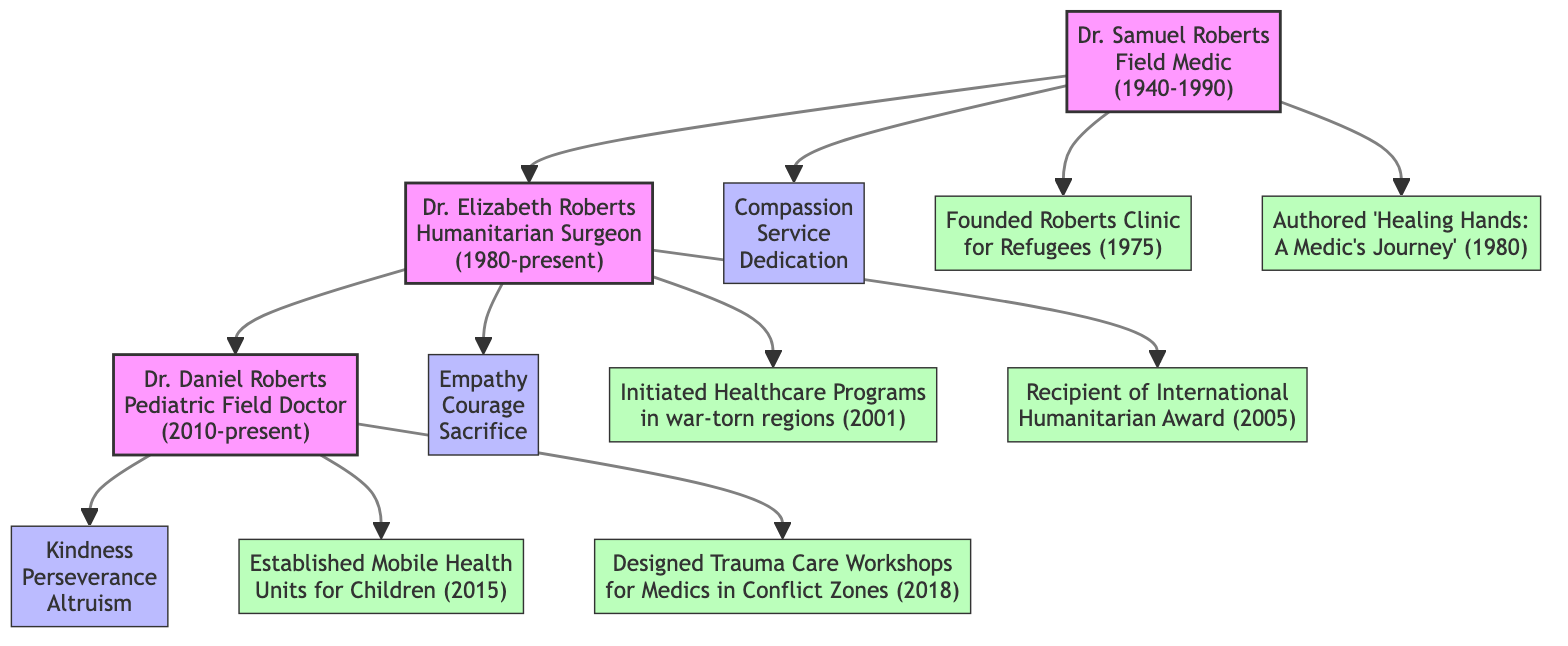What values did Dr. Samuel Roberts emphasize? The diagram indicates that Dr. Samuel Roberts emphasized three values: Compassion, Service, and Dedication. These values are displayed as nodes directly connected to his name.
Answer: Compassion, Service, Dedication Who initiated healthcare programs in war-torn regions? According to the diagram, Dr. Elizabeth Roberts is responsible for initiating healthcare programs in war-torn regions, as shown by the associated achievement node linked to her.
Answer: Dr. Elizabeth Roberts How many notable achievements does Dr. Daniel Roberts have listed? The diagram shows two notable achievements directly connected to Dr. Daniel Roberts. By counting the edges leading to his achievement nodes, we confirm the total.
Answer: 2 What is Dr. Elizabeth Roberts' notable award? The diagram states that Dr. Elizabeth Roberts received the International Humanitarian Award, which is listed as one of her notable achievements.
Answer: International Humanitarian Award Which family member worked as a Pediatric Field Doctor? The diagram clearly indicates that Dr. Daniel Roberts holds the title of Pediatric Field Doctor, linking it directly to his name.
Answer: Dr. Daniel Roberts What year was the Roberts Clinic for Refugees founded? The diagram specifies that the Roberts Clinic for Refugees was founded in 1975, which is indicated beside the achievement node for Dr. Samuel Roberts.
Answer: 1975 What values are associated with Dr. Daniel Roberts? Dr. Daniel Roberts is associated with three values: Kindness, Perseverance, and Altruism, which are linked to him in the diagram.
Answer: Kindness, Perseverance, Altruism Who is connected to Dr. Samuel Roberts? The diagram indicates that Dr. Elizabeth Roberts is connected to Dr. Samuel Roberts as his successor in the family tree, which is apparent from the edge drawn between them.
Answer: Dr. Elizabeth Roberts What period did Dr. Samuel Roberts practice? According to the diagram, the practice period of Dr. Samuel Roberts is indicated as 1940-1990, listed alongside his name in the diagram.
Answer: 1940-1990 